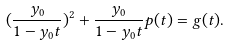<formula> <loc_0><loc_0><loc_500><loc_500>( \frac { y _ { 0 } } { 1 - y _ { 0 } t } ) ^ { 2 } + \frac { y _ { 0 } } { 1 - y _ { 0 } t } p ( t ) = g ( t ) .</formula> 